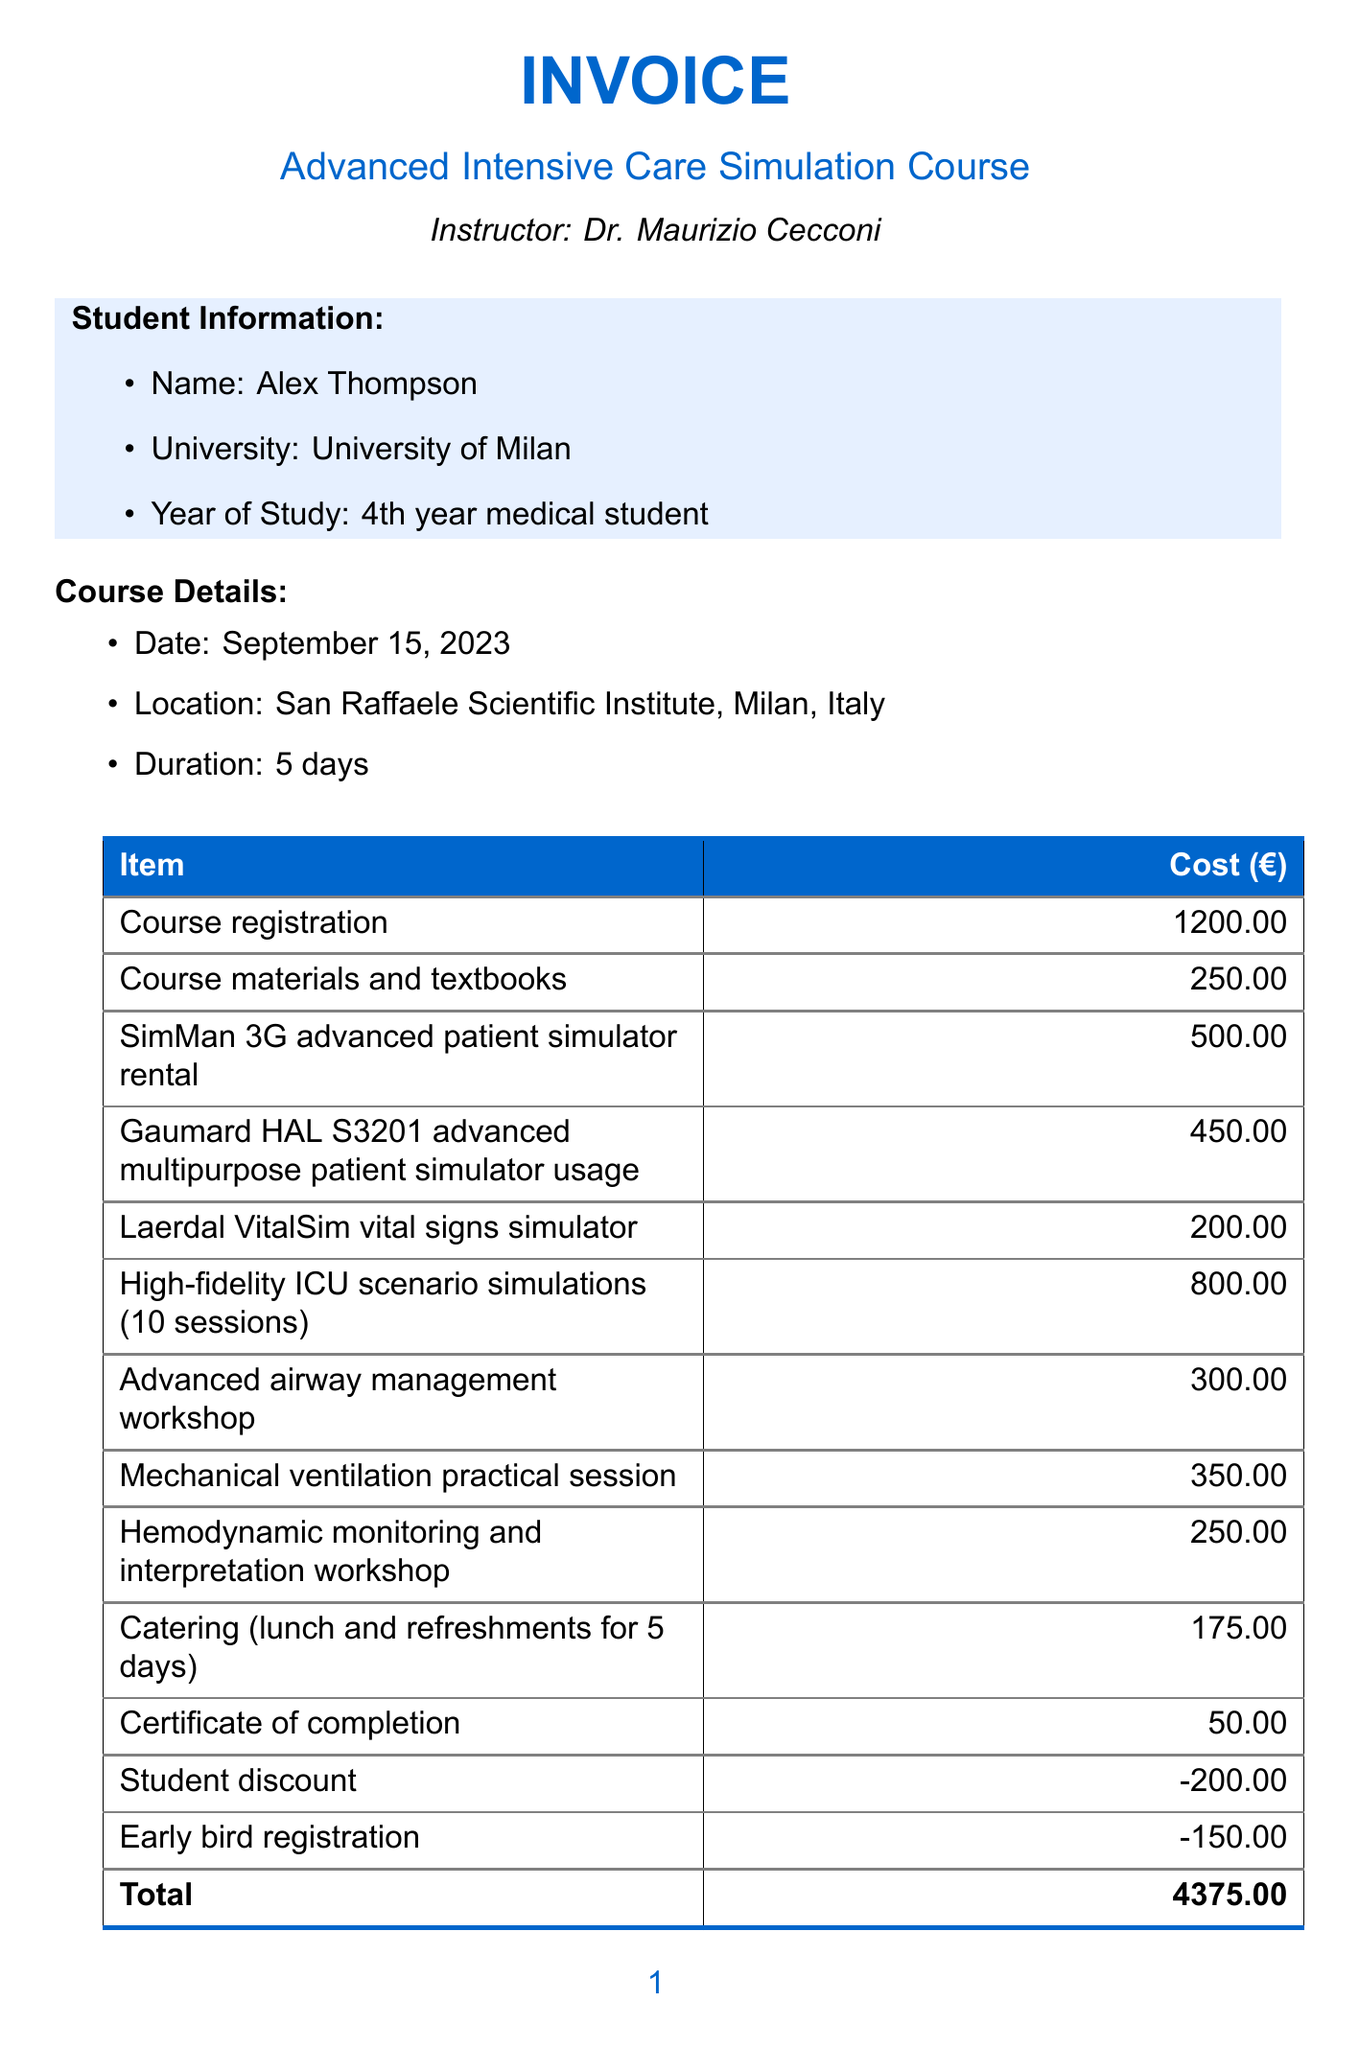What is the course name? The course name is listed at the top of the invoice.
Answer: Advanced Intensive Care Simulation Course Who is the instructor? The name of the instructor is mentioned below the course name.
Answer: Dr. Maurizio Cecconi What is the total cost? The total cost is provided at the bottom of the cost breakdown section.
Answer: 4375.00 When is the due date for payment? The due date for payment is specified under the payment terms section.
Answer: August 15, 2023 What is the cost of the course registration? The cost of the course registration is listed in the course fees section.
Answer: 1200.00 How many CME credits do participants receive? The number of CME credits is stated in the additional notes section.
Answer: 25 What discount applies for early registration? The document specifies the discount for early registration.
Answer: -150.00 How long is the course duration? The duration of the course is mentioned in the course details section.
Answer: 5 days What is included in the catering expense? Catering expense is detailed in the additional expenses part of the invoice.
Answer: lunch and refreshments for 5 days 